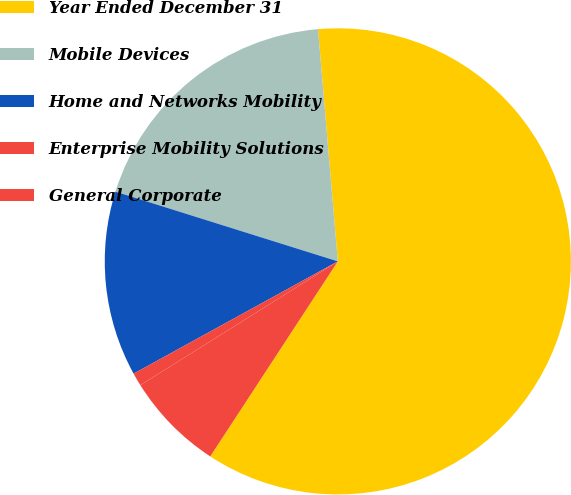<chart> <loc_0><loc_0><loc_500><loc_500><pie_chart><fcel>Year Ended December 31<fcel>Mobile Devices<fcel>Home and Networks Mobility<fcel>Enterprise Mobility Solutions<fcel>General Corporate<nl><fcel>60.58%<fcel>18.81%<fcel>12.84%<fcel>0.91%<fcel>6.87%<nl></chart> 